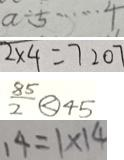Convert formula to latex. <formula><loc_0><loc_0><loc_500><loc_500>a \div 5 \cdots 4 
 2 \times 4 = 7 2 0 7 
 \frac { 8 5 } { 2 } \textcircled { < } 4 5 
 1 4 = 1 \times 1 4</formula> 